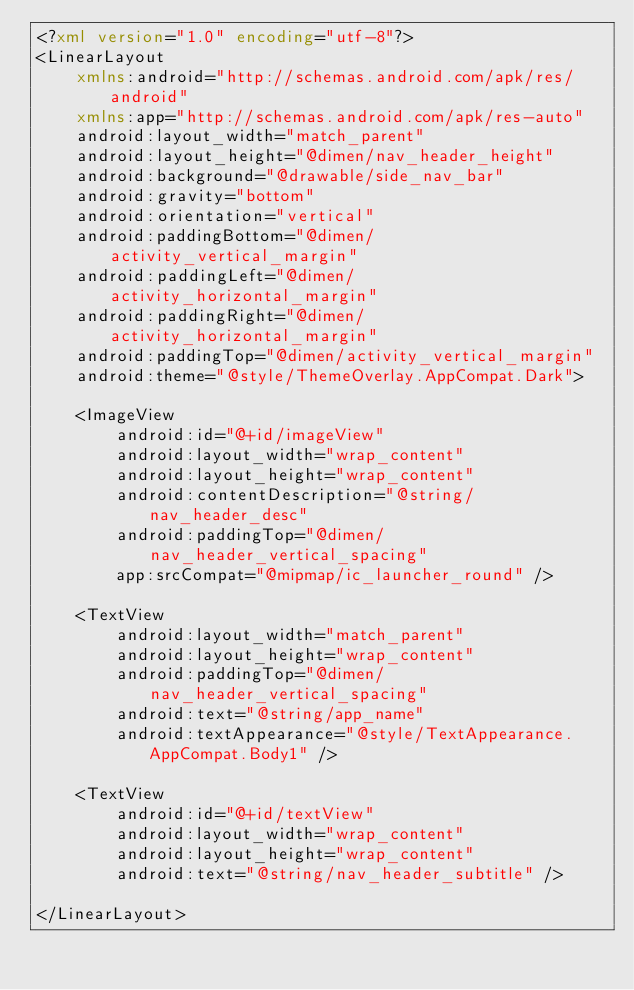Convert code to text. <code><loc_0><loc_0><loc_500><loc_500><_XML_><?xml version="1.0" encoding="utf-8"?>
<LinearLayout
    xmlns:android="http://schemas.android.com/apk/res/android"
    xmlns:app="http://schemas.android.com/apk/res-auto"
    android:layout_width="match_parent"
    android:layout_height="@dimen/nav_header_height"
    android:background="@drawable/side_nav_bar"
    android:gravity="bottom"
    android:orientation="vertical"
    android:paddingBottom="@dimen/activity_vertical_margin"
    android:paddingLeft="@dimen/activity_horizontal_margin"
    android:paddingRight="@dimen/activity_horizontal_margin"
    android:paddingTop="@dimen/activity_vertical_margin"
    android:theme="@style/ThemeOverlay.AppCompat.Dark">

    <ImageView
        android:id="@+id/imageView"
        android:layout_width="wrap_content"
        android:layout_height="wrap_content"
        android:contentDescription="@string/nav_header_desc"
        android:paddingTop="@dimen/nav_header_vertical_spacing"
        app:srcCompat="@mipmap/ic_launcher_round" />

    <TextView
        android:layout_width="match_parent"
        android:layout_height="wrap_content"
        android:paddingTop="@dimen/nav_header_vertical_spacing"
        android:text="@string/app_name"
        android:textAppearance="@style/TextAppearance.AppCompat.Body1" />

    <TextView
        android:id="@+id/textView"
        android:layout_width="wrap_content"
        android:layout_height="wrap_content"
        android:text="@string/nav_header_subtitle" />

</LinearLayout>
</code> 